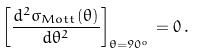<formula> <loc_0><loc_0><loc_500><loc_500>\left [ \frac { d ^ { 2 } \sigma _ { M o t t } ( \theta ) } { d \theta ^ { 2 } } \right ] _ { \theta = 9 0 ^ { o } } = 0 \, .</formula> 